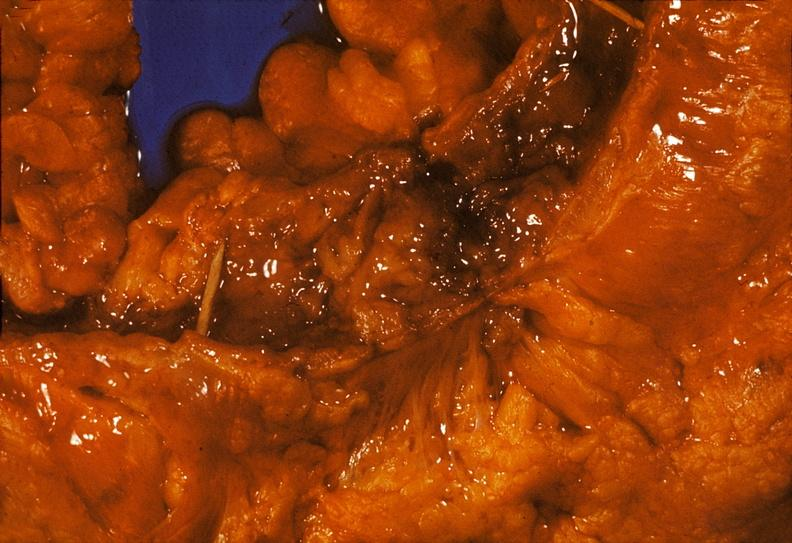where does this belong to?
Answer the question using a single word or phrase. Gastrointestinal system 